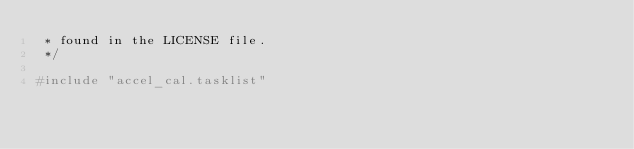<code> <loc_0><loc_0><loc_500><loc_500><_C_> * found in the LICENSE file.
 */

#include "accel_cal.tasklist"
</code> 